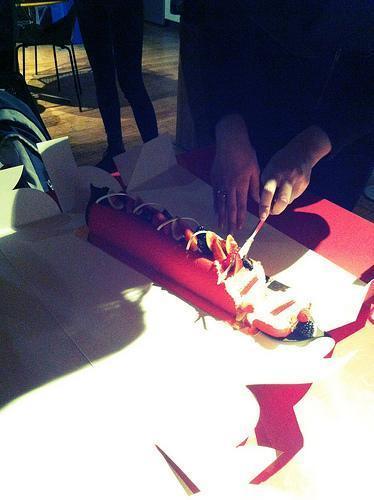How many knives are there?
Give a very brief answer. 1. 